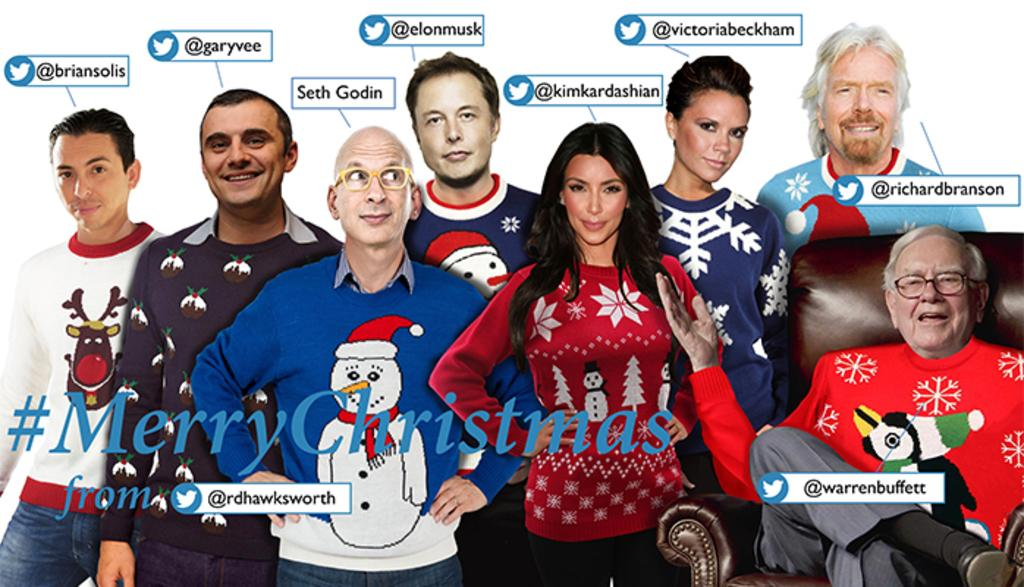<image>
Summarize the visual content of the image. A Merry Christmas card with the twitter handles for Kim Kardashian and other celebraties. 